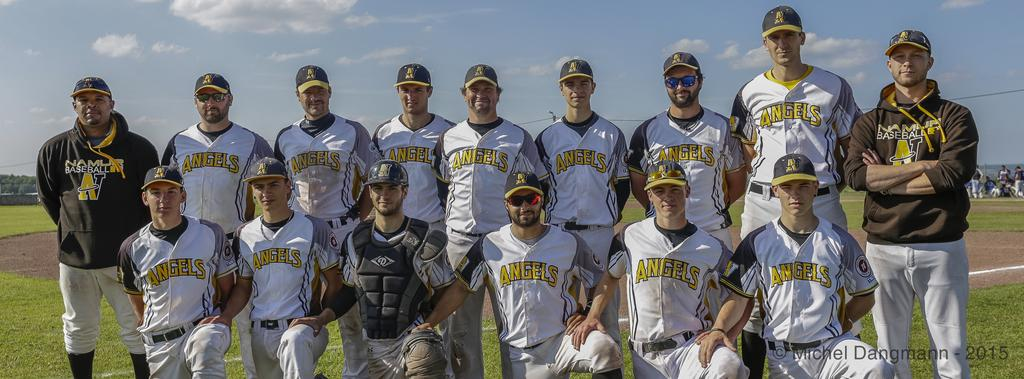How many people are in the image? There are people in the image, but the exact number is not specified. What is the position of the people in the image? The people are on the ground in the image. What can be seen in the background of the image? There are trees, a pole with wires, and the sky visible in the background of the image. What is the weather like in the image? The presence of clouds in the sky suggests that it might be partly cloudy. Can you see a ghost attacking the people in the image? No, there is no ghost or any attack visible in the image. 